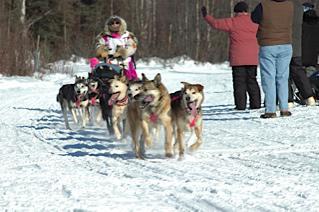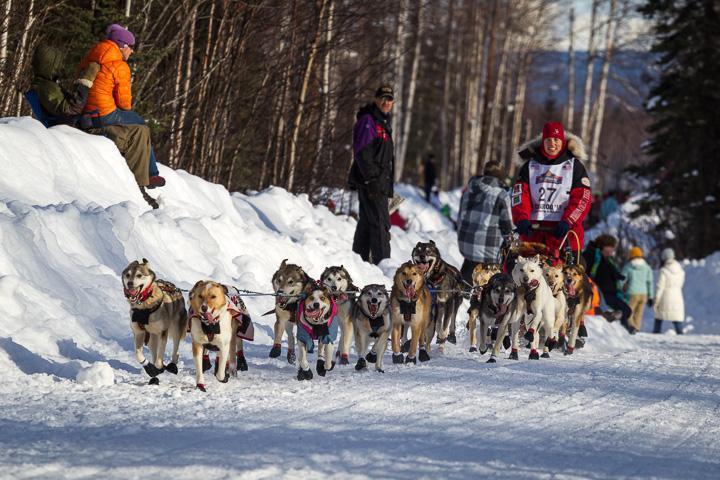The first image is the image on the left, the second image is the image on the right. For the images shown, is this caption "One of the images shows exactly two dogs pulling the sled." true? Answer yes or no. No. The first image is the image on the left, the second image is the image on the right. Analyze the images presented: Is the assertion "A crowd of people stand packed together on the left to watch a sled dog race, in one image." valid? Answer yes or no. No. 